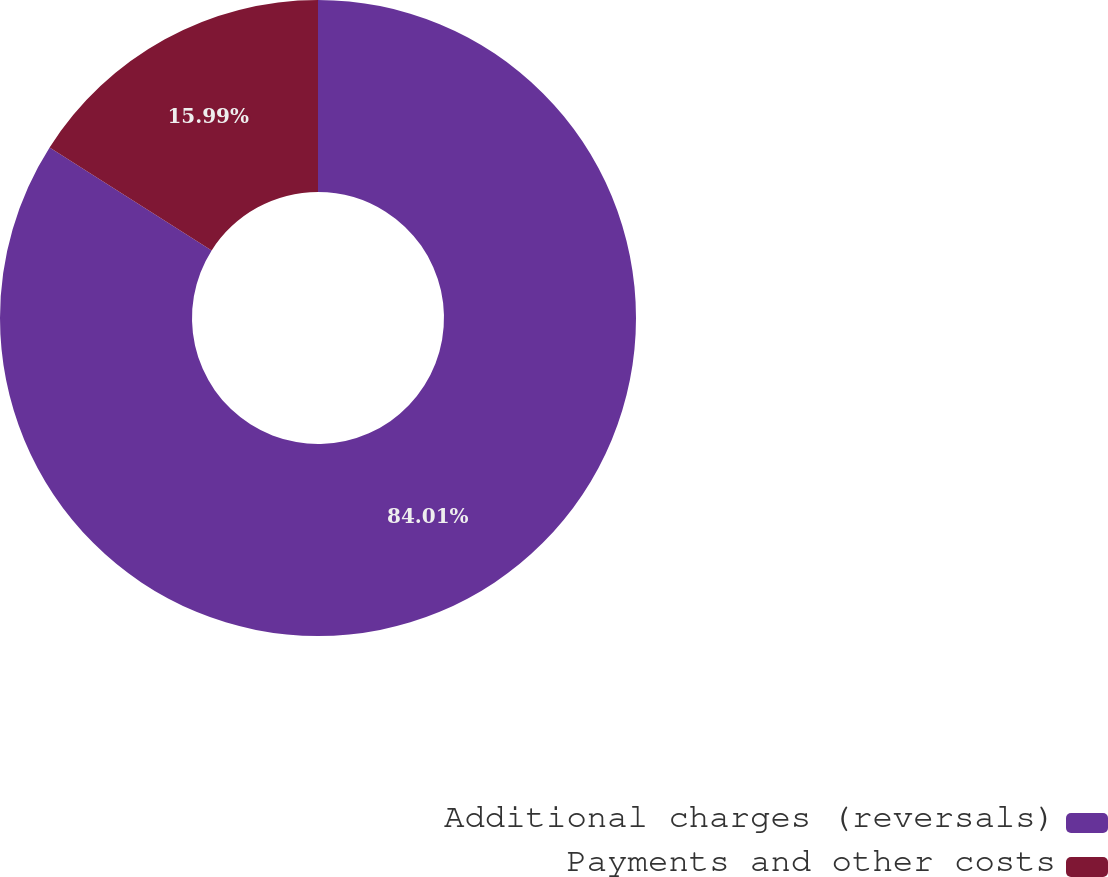Convert chart. <chart><loc_0><loc_0><loc_500><loc_500><pie_chart><fcel>Additional charges (reversals)<fcel>Payments and other costs<nl><fcel>84.01%<fcel>15.99%<nl></chart> 